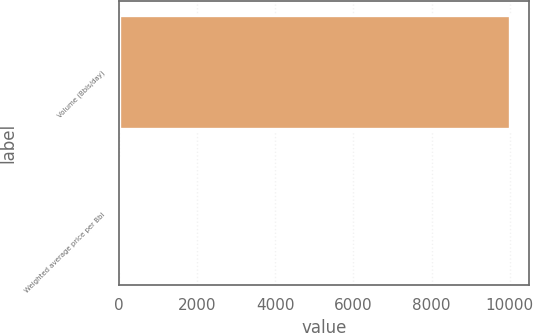<chart> <loc_0><loc_0><loc_500><loc_500><bar_chart><fcel>Volume (Bbls/day)<fcel>Weighted average price per Bbl<nl><fcel>10000<fcel>0.82<nl></chart> 